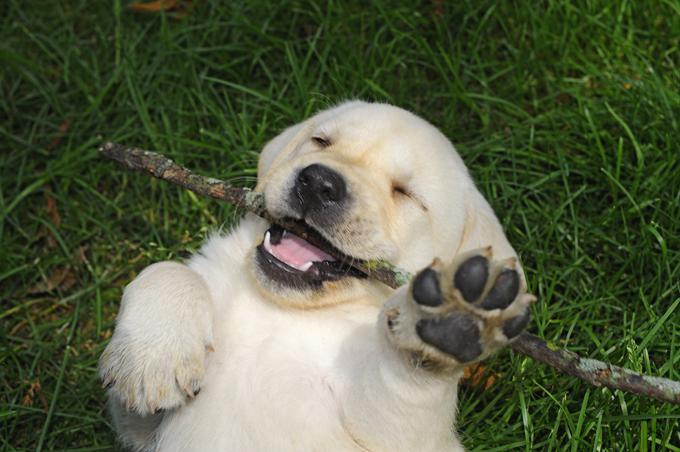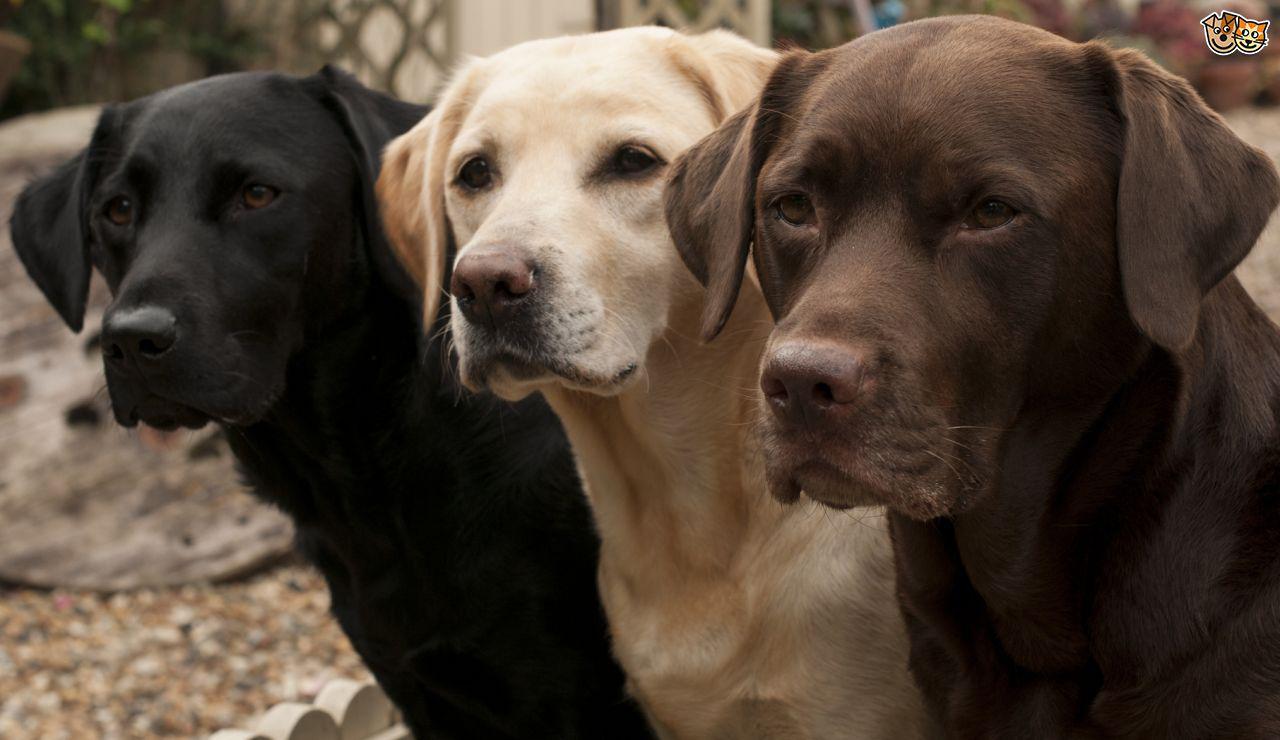The first image is the image on the left, the second image is the image on the right. Given the left and right images, does the statement "There are no more than four labrador retrievers" hold true? Answer yes or no. Yes. The first image is the image on the left, the second image is the image on the right. For the images shown, is this caption "There are two dogs" true? Answer yes or no. No. 